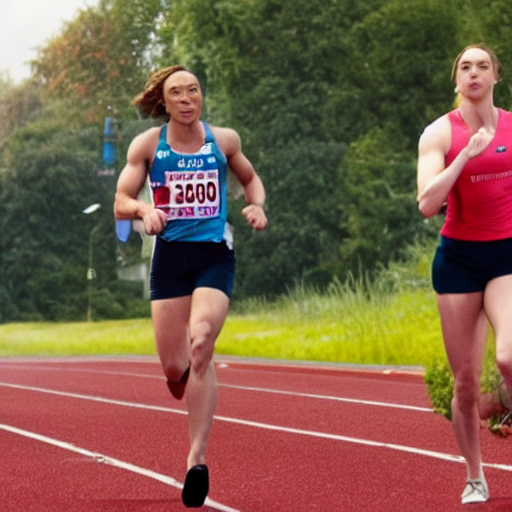What is the overall clarity of the image? Upon inspection, the image appears to exhibit average clarity. The focus on the foreground, where the athlete is prominently featured, is relatively sharp, allowing us to make out details such as facial expressions and clothing textures. However, the background details are somewhat blurred, which is often a result of movement or a shallow depth of field in action photography. This selective focus could be intentional to emphasize the subject but does affect the overall clarity. So, while it doesn't reach the level of high-definition sharpness throughout, the image provides sufficient clarity for its main subject. 